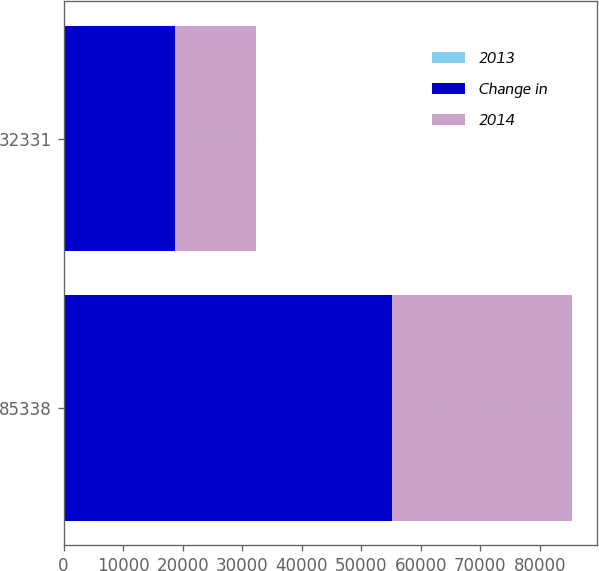Convert chart to OTSL. <chart><loc_0><loc_0><loc_500><loc_500><stacked_bar_chart><ecel><fcel>85338<fcel>32331<nl><fcel>2013<fcel>14.6<fcel>5.5<nl><fcel>Change in<fcel>55115<fcel>18688<nl><fcel>2014<fcel>30223<fcel>13643<nl></chart> 